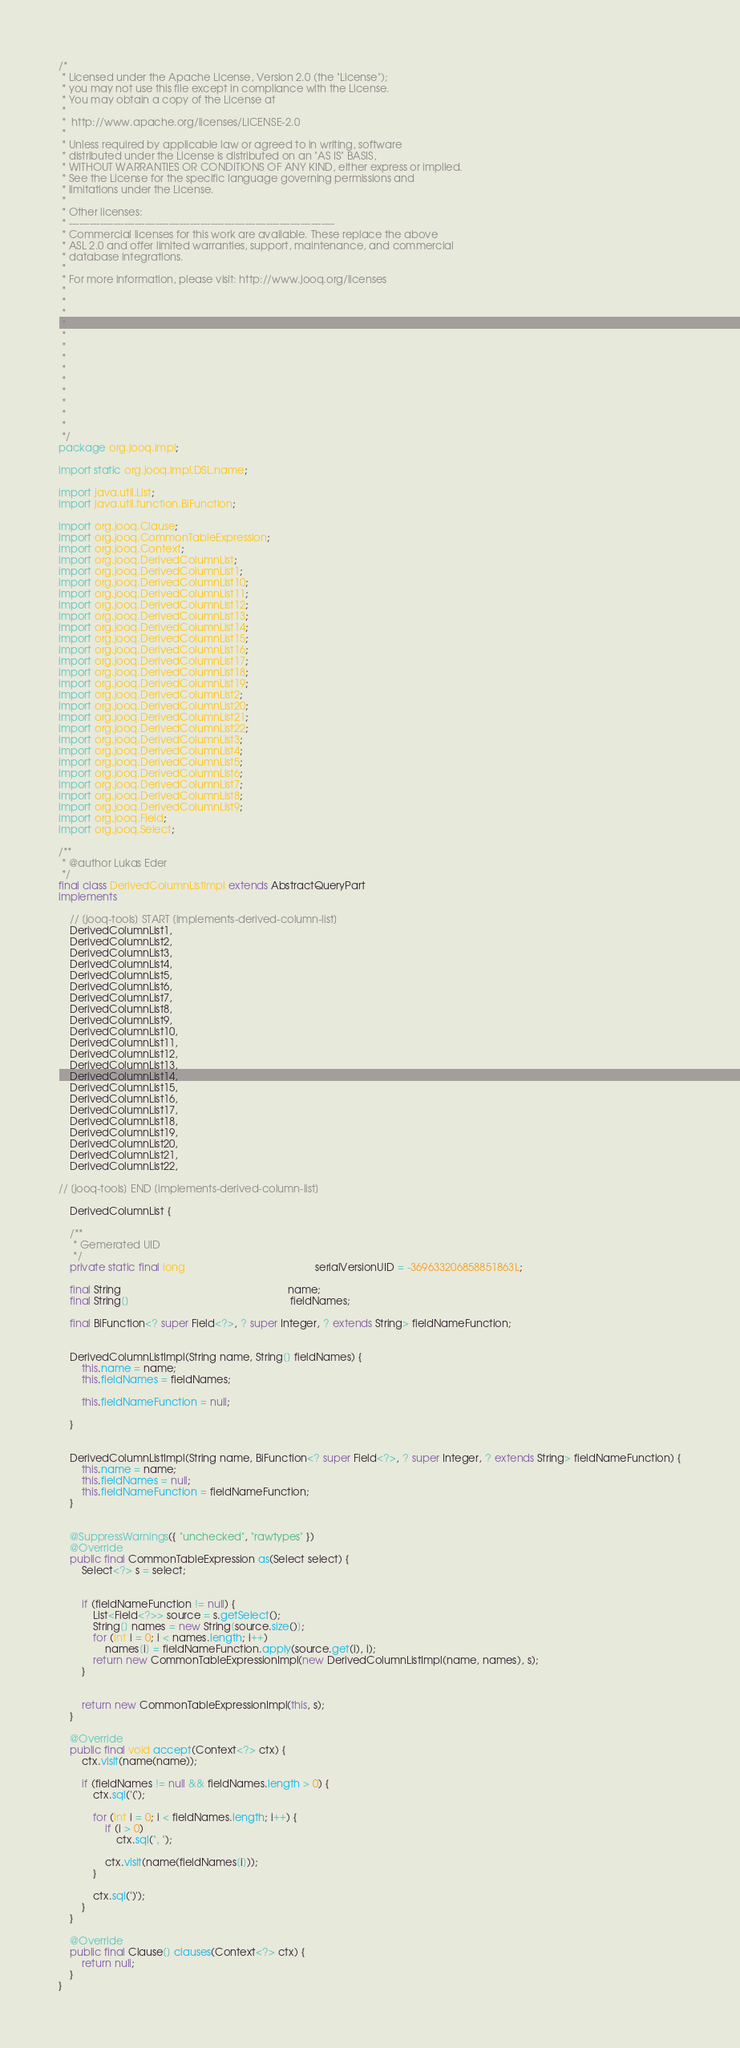<code> <loc_0><loc_0><loc_500><loc_500><_Java_>/*
 * Licensed under the Apache License, Version 2.0 (the "License");
 * you may not use this file except in compliance with the License.
 * You may obtain a copy of the License at
 *
 *  http://www.apache.org/licenses/LICENSE-2.0
 *
 * Unless required by applicable law or agreed to in writing, software
 * distributed under the License is distributed on an "AS IS" BASIS,
 * WITHOUT WARRANTIES OR CONDITIONS OF ANY KIND, either express or implied.
 * See the License for the specific language governing permissions and
 * limitations under the License.
 *
 * Other licenses:
 * -----------------------------------------------------------------------------
 * Commercial licenses for this work are available. These replace the above
 * ASL 2.0 and offer limited warranties, support, maintenance, and commercial
 * database integrations.
 *
 * For more information, please visit: http://www.jooq.org/licenses
 *
 *
 *
 *
 *
 *
 *
 *
 *
 *
 *
 *
 *
 */
package org.jooq.impl;

import static org.jooq.impl.DSL.name;

import java.util.List;
import java.util.function.BiFunction;

import org.jooq.Clause;
import org.jooq.CommonTableExpression;
import org.jooq.Context;
import org.jooq.DerivedColumnList;
import org.jooq.DerivedColumnList1;
import org.jooq.DerivedColumnList10;
import org.jooq.DerivedColumnList11;
import org.jooq.DerivedColumnList12;
import org.jooq.DerivedColumnList13;
import org.jooq.DerivedColumnList14;
import org.jooq.DerivedColumnList15;
import org.jooq.DerivedColumnList16;
import org.jooq.DerivedColumnList17;
import org.jooq.DerivedColumnList18;
import org.jooq.DerivedColumnList19;
import org.jooq.DerivedColumnList2;
import org.jooq.DerivedColumnList20;
import org.jooq.DerivedColumnList21;
import org.jooq.DerivedColumnList22;
import org.jooq.DerivedColumnList3;
import org.jooq.DerivedColumnList4;
import org.jooq.DerivedColumnList5;
import org.jooq.DerivedColumnList6;
import org.jooq.DerivedColumnList7;
import org.jooq.DerivedColumnList8;
import org.jooq.DerivedColumnList9;
import org.jooq.Field;
import org.jooq.Select;

/**
 * @author Lukas Eder
 */
final class DerivedColumnListImpl extends AbstractQueryPart
implements

    // [jooq-tools] START [implements-derived-column-list]
    DerivedColumnList1,
    DerivedColumnList2,
    DerivedColumnList3,
    DerivedColumnList4,
    DerivedColumnList5,
    DerivedColumnList6,
    DerivedColumnList7,
    DerivedColumnList8,
    DerivedColumnList9,
    DerivedColumnList10,
    DerivedColumnList11,
    DerivedColumnList12,
    DerivedColumnList13,
    DerivedColumnList14,
    DerivedColumnList15,
    DerivedColumnList16,
    DerivedColumnList17,
    DerivedColumnList18,
    DerivedColumnList19,
    DerivedColumnList20,
    DerivedColumnList21,
    DerivedColumnList22,

// [jooq-tools] END [implements-derived-column-list]

    DerivedColumnList {

    /**
     * Gemerated UID
     */
    private static final long                                             serialVersionUID = -369633206858851863L;

    final String                                                          name;
    final String[]                                                        fieldNames;

    final BiFunction<? super Field<?>, ? super Integer, ? extends String> fieldNameFunction;


    DerivedColumnListImpl(String name, String[] fieldNames) {
        this.name = name;
        this.fieldNames = fieldNames;

        this.fieldNameFunction = null;

    }


    DerivedColumnListImpl(String name, BiFunction<? super Field<?>, ? super Integer, ? extends String> fieldNameFunction) {
        this.name = name;
        this.fieldNames = null;
        this.fieldNameFunction = fieldNameFunction;
    }


    @SuppressWarnings({ "unchecked", "rawtypes" })
    @Override
    public final CommonTableExpression as(Select select) {
        Select<?> s = select;


        if (fieldNameFunction != null) {
            List<Field<?>> source = s.getSelect();
            String[] names = new String[source.size()];
            for (int i = 0; i < names.length; i++)
                names[i] = fieldNameFunction.apply(source.get(i), i);
            return new CommonTableExpressionImpl(new DerivedColumnListImpl(name, names), s);
        }


        return new CommonTableExpressionImpl(this, s);
    }

    @Override
    public final void accept(Context<?> ctx) {
        ctx.visit(name(name));

        if (fieldNames != null && fieldNames.length > 0) {
            ctx.sql('(');

            for (int i = 0; i < fieldNames.length; i++) {
                if (i > 0)
                    ctx.sql(", ");

                ctx.visit(name(fieldNames[i]));
            }

            ctx.sql(')');
        }
    }

    @Override
    public final Clause[] clauses(Context<?> ctx) {
        return null;
    }
}
</code> 